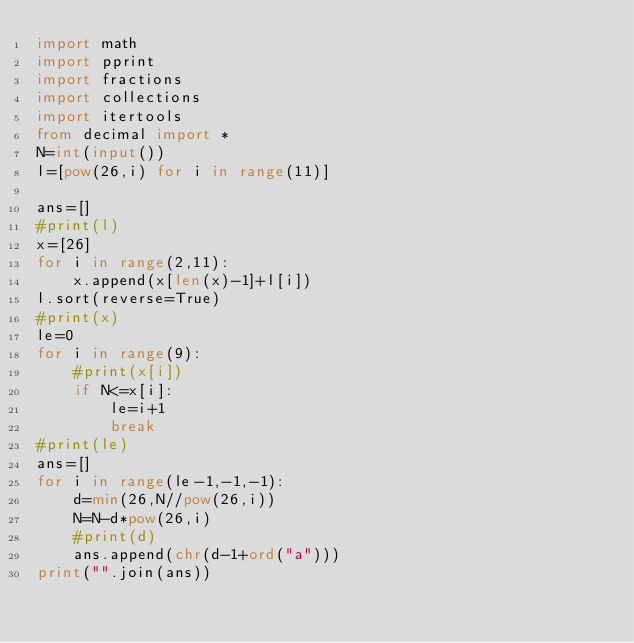Convert code to text. <code><loc_0><loc_0><loc_500><loc_500><_Python_>import math
import pprint
import fractions
import collections
import itertools
from decimal import *
N=int(input())
l=[pow(26,i) for i in range(11)]

ans=[]
#print(l)
x=[26]
for i in range(2,11):
    x.append(x[len(x)-1]+l[i])
l.sort(reverse=True)
#print(x)
le=0
for i in range(9):
    #print(x[i])
    if N<=x[i]:
        le=i+1
        break
#print(le)
ans=[]
for i in range(le-1,-1,-1):
    d=min(26,N//pow(26,i))
    N=N-d*pow(26,i)
    #print(d)
    ans.append(chr(d-1+ord("a")))
print("".join(ans))
</code> 